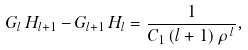Convert formula to latex. <formula><loc_0><loc_0><loc_500><loc_500>G _ { l } \, H _ { l + 1 } - G _ { l + 1 } \, H _ { l } = \frac { 1 } { C _ { 1 } \, ( l + 1 ) \, \rho \, ^ { l } } ,</formula> 